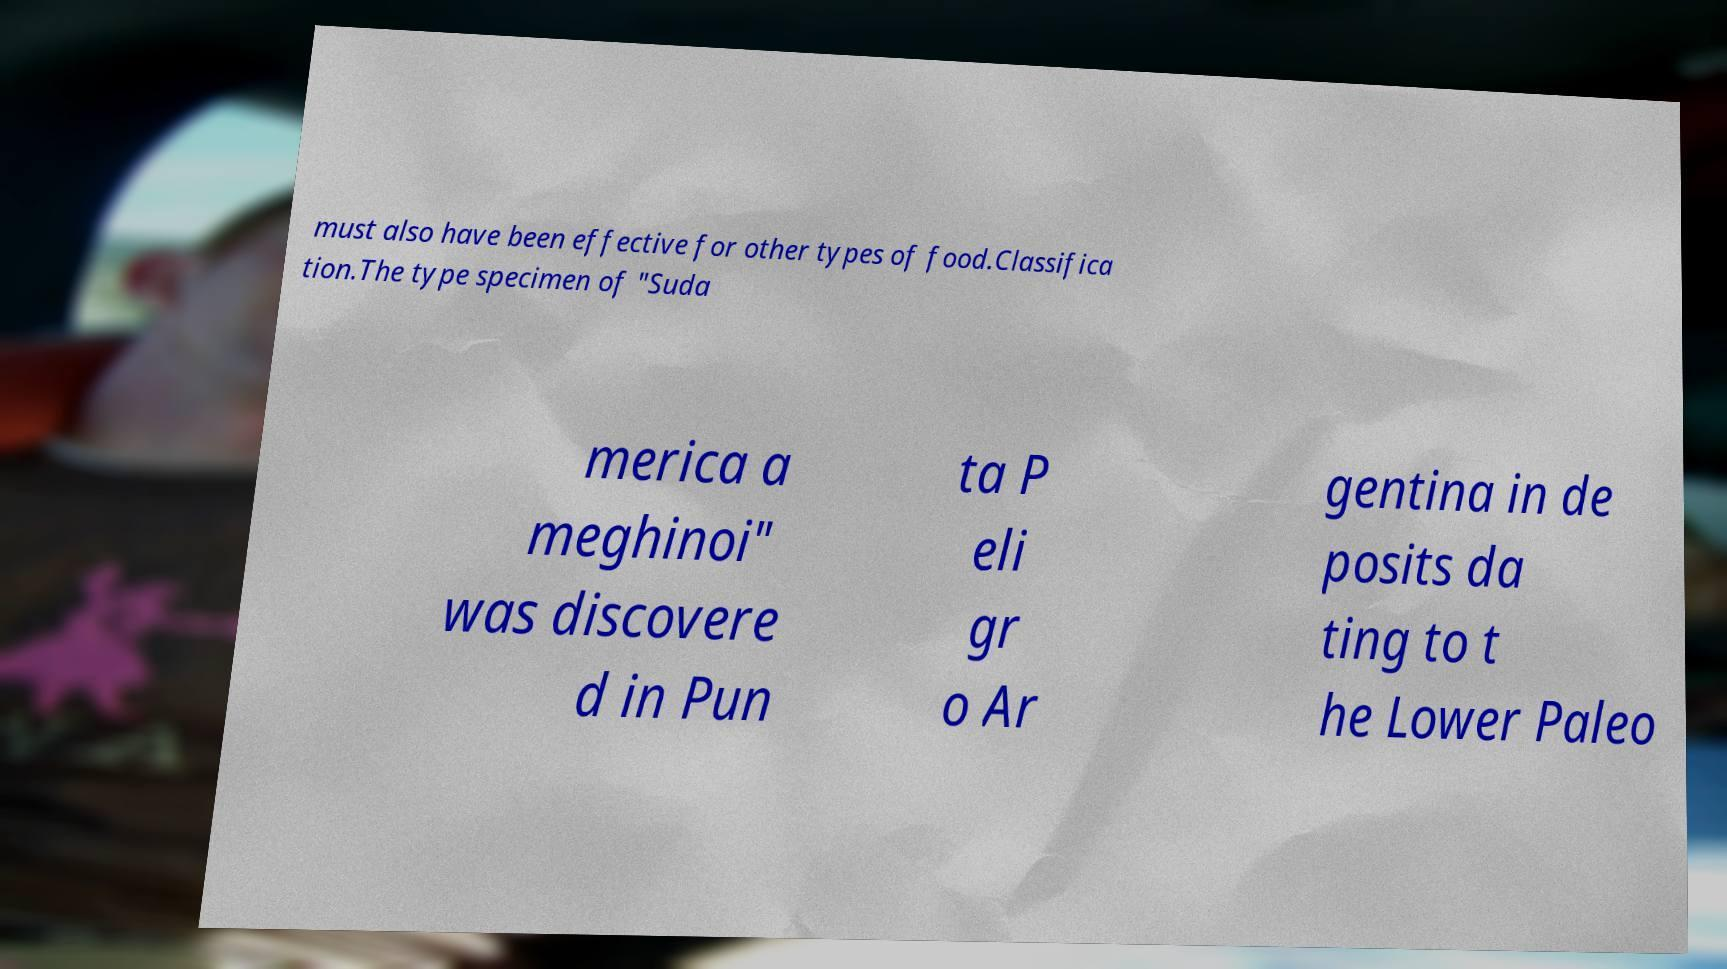Please identify and transcribe the text found in this image. must also have been effective for other types of food.Classifica tion.The type specimen of "Suda merica a meghinoi" was discovere d in Pun ta P eli gr o Ar gentina in de posits da ting to t he Lower Paleo 